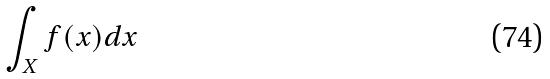Convert formula to latex. <formula><loc_0><loc_0><loc_500><loc_500>\int _ { X } f ( x ) d x</formula> 